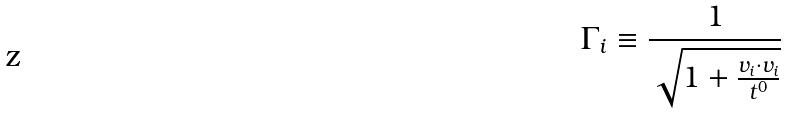Convert formula to latex. <formula><loc_0><loc_0><loc_500><loc_500>\Gamma _ { i } \equiv \frac { 1 } { \sqrt { 1 + \frac { v _ { i } \cdot v _ { i } } { t ^ { 0 } } } }</formula> 